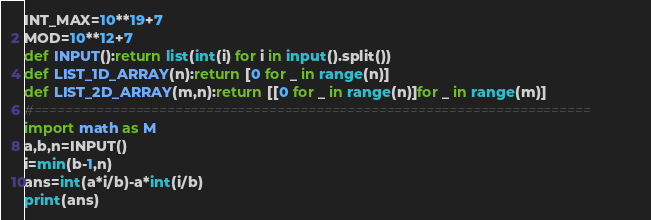<code> <loc_0><loc_0><loc_500><loc_500><_Python_>INT_MAX=10**19+7
MOD=10**12+7
def INPUT():return list(int(i) for i in input().split())
def LIST_1D_ARRAY(n):return [0 for _ in range(n)]
def LIST_2D_ARRAY(m,n):return [[0 for _ in range(n)]for _ in range(m)]
#=======================================================================
import math as M
a,b,n=INPUT()
i=min(b-1,n)
ans=int(a*i/b)-a*int(i/b)
print(ans)
</code> 